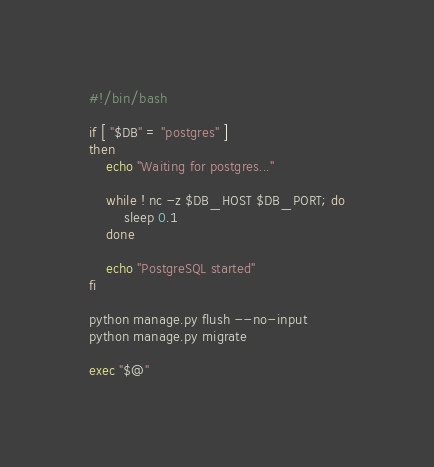Convert code to text. <code><loc_0><loc_0><loc_500><loc_500><_Bash_>#!/bin/bash

if [ "$DB" = "postgres" ]
then
    echo "Waiting for postgres..."

    while ! nc -z $DB_HOST $DB_PORT; do
        sleep 0.1
    done

    echo "PostgreSQL started"
fi

python manage.py flush --no-input
python manage.py migrate

exec "$@"</code> 